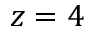Convert formula to latex. <formula><loc_0><loc_0><loc_500><loc_500>z = 4</formula> 